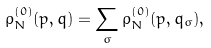<formula> <loc_0><loc_0><loc_500><loc_500>\rho _ { N } ^ { ( 0 ) } ( p , q ) = \sum _ { \sigma } \rho _ { N } ^ { ( 0 ) } ( p , q _ { \sigma } ) ,</formula> 